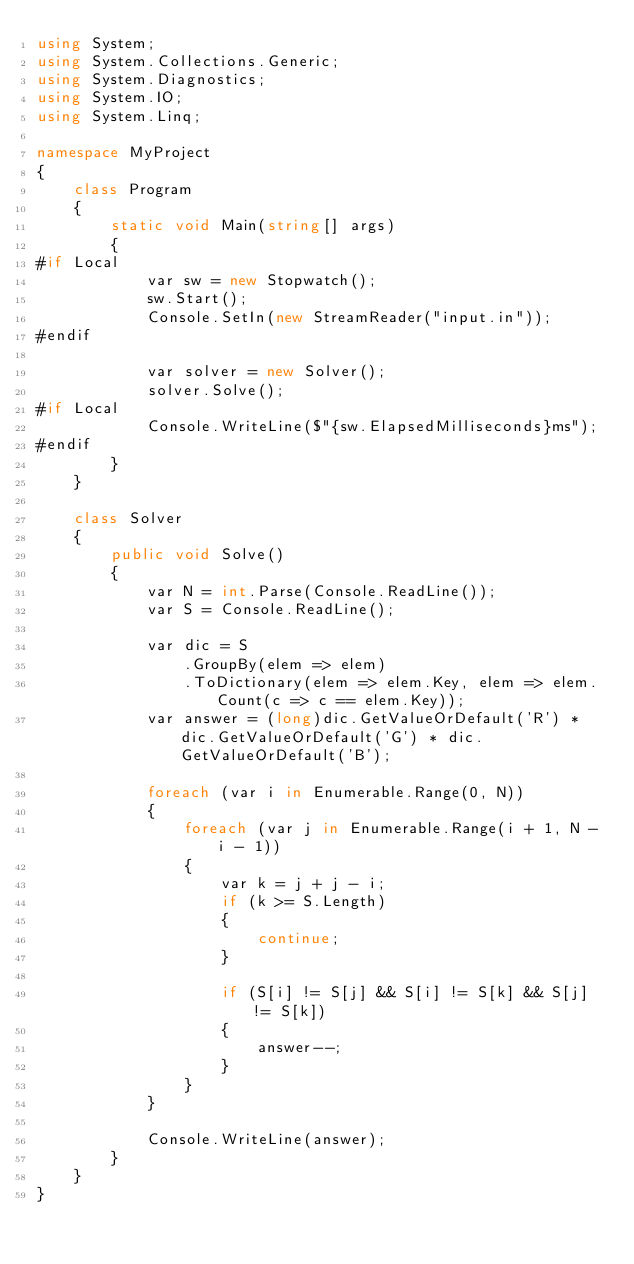<code> <loc_0><loc_0><loc_500><loc_500><_C#_>using System;
using System.Collections.Generic;
using System.Diagnostics;
using System.IO;
using System.Linq;

namespace MyProject
{
    class Program
    {
        static void Main(string[] args)
        {
#if Local
            var sw = new Stopwatch();
            sw.Start();
            Console.SetIn(new StreamReader("input.in"));
#endif

            var solver = new Solver();
            solver.Solve();
#if Local
            Console.WriteLine($"{sw.ElapsedMilliseconds}ms");
#endif
        }
    }

    class Solver
    {
        public void Solve()
        {
            var N = int.Parse(Console.ReadLine());
            var S = Console.ReadLine();

            var dic = S
                .GroupBy(elem => elem)
                .ToDictionary(elem => elem.Key, elem => elem.Count(c => c == elem.Key));
            var answer = (long)dic.GetValueOrDefault('R') * dic.GetValueOrDefault('G') * dic.GetValueOrDefault('B');

            foreach (var i in Enumerable.Range(0, N))
            {
                foreach (var j in Enumerable.Range(i + 1, N - i - 1))
                {
                    var k = j + j - i;
                    if (k >= S.Length)
                    {
                        continue;
                    }

                    if (S[i] != S[j] && S[i] != S[k] && S[j] != S[k])
                    {
                        answer--;
                    }
                }
            }

            Console.WriteLine(answer);
        }
    }
}
</code> 